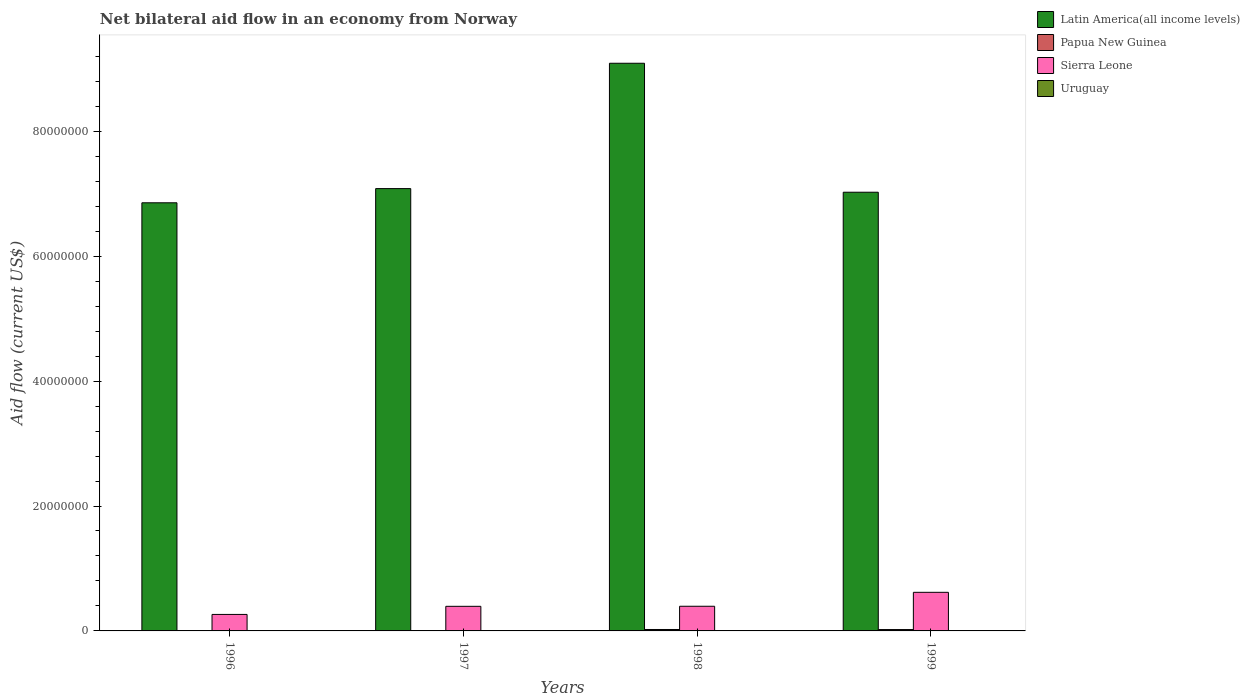How many groups of bars are there?
Offer a terse response. 4. How many bars are there on the 1st tick from the left?
Ensure brevity in your answer.  4. What is the label of the 3rd group of bars from the left?
Offer a terse response. 1998. In how many cases, is the number of bars for a given year not equal to the number of legend labels?
Offer a very short reply. 0. What is the net bilateral aid flow in Sierra Leone in 1999?
Offer a terse response. 6.18e+06. Across all years, what is the maximum net bilateral aid flow in Sierra Leone?
Provide a succinct answer. 6.18e+06. Across all years, what is the minimum net bilateral aid flow in Sierra Leone?
Your response must be concise. 2.64e+06. In which year was the net bilateral aid flow in Papua New Guinea maximum?
Your answer should be compact. 1998. What is the difference between the net bilateral aid flow in Uruguay in 1996 and that in 1997?
Offer a terse response. 3.00e+04. What is the difference between the net bilateral aid flow in Uruguay in 1997 and the net bilateral aid flow in Sierra Leone in 1999?
Your answer should be compact. -6.16e+06. What is the average net bilateral aid flow in Papua New Guinea per year?
Your answer should be compact. 1.28e+05. In the year 1999, what is the difference between the net bilateral aid flow in Uruguay and net bilateral aid flow in Sierra Leone?
Offer a very short reply. -6.13e+06. In how many years, is the net bilateral aid flow in Sierra Leone greater than 84000000 US$?
Ensure brevity in your answer.  0. What is the ratio of the net bilateral aid flow in Sierra Leone in 1996 to that in 1999?
Ensure brevity in your answer.  0.43. Is the net bilateral aid flow in Latin America(all income levels) in 1996 less than that in 1999?
Provide a succinct answer. Yes. Is the difference between the net bilateral aid flow in Uruguay in 1996 and 1998 greater than the difference between the net bilateral aid flow in Sierra Leone in 1996 and 1998?
Provide a short and direct response. Yes. What is the difference between the highest and the second highest net bilateral aid flow in Uruguay?
Offer a terse response. 0. In how many years, is the net bilateral aid flow in Sierra Leone greater than the average net bilateral aid flow in Sierra Leone taken over all years?
Your answer should be very brief. 1. What does the 4th bar from the left in 1997 represents?
Your response must be concise. Uruguay. What does the 2nd bar from the right in 1996 represents?
Keep it short and to the point. Sierra Leone. Is it the case that in every year, the sum of the net bilateral aid flow in Latin America(all income levels) and net bilateral aid flow in Uruguay is greater than the net bilateral aid flow in Papua New Guinea?
Ensure brevity in your answer.  Yes. How many bars are there?
Give a very brief answer. 16. Are all the bars in the graph horizontal?
Provide a succinct answer. No. What is the difference between two consecutive major ticks on the Y-axis?
Ensure brevity in your answer.  2.00e+07. Does the graph contain any zero values?
Your answer should be compact. No. How many legend labels are there?
Provide a succinct answer. 4. What is the title of the graph?
Provide a short and direct response. Net bilateral aid flow in an economy from Norway. Does "Lesotho" appear as one of the legend labels in the graph?
Offer a very short reply. No. What is the Aid flow (current US$) in Latin America(all income levels) in 1996?
Provide a succinct answer. 6.86e+07. What is the Aid flow (current US$) of Sierra Leone in 1996?
Ensure brevity in your answer.  2.64e+06. What is the Aid flow (current US$) of Latin America(all income levels) in 1997?
Offer a very short reply. 7.08e+07. What is the Aid flow (current US$) in Papua New Guinea in 1997?
Your answer should be compact. 3.00e+04. What is the Aid flow (current US$) of Sierra Leone in 1997?
Make the answer very short. 3.94e+06. What is the Aid flow (current US$) of Latin America(all income levels) in 1998?
Make the answer very short. 9.09e+07. What is the Aid flow (current US$) of Papua New Guinea in 1998?
Your answer should be very brief. 2.30e+05. What is the Aid flow (current US$) of Sierra Leone in 1998?
Keep it short and to the point. 3.95e+06. What is the Aid flow (current US$) in Latin America(all income levels) in 1999?
Provide a succinct answer. 7.02e+07. What is the Aid flow (current US$) of Sierra Leone in 1999?
Your answer should be compact. 6.18e+06. Across all years, what is the maximum Aid flow (current US$) in Latin America(all income levels)?
Offer a terse response. 9.09e+07. Across all years, what is the maximum Aid flow (current US$) of Sierra Leone?
Offer a terse response. 6.18e+06. Across all years, what is the maximum Aid flow (current US$) of Uruguay?
Keep it short and to the point. 5.00e+04. Across all years, what is the minimum Aid flow (current US$) of Latin America(all income levels)?
Offer a very short reply. 6.86e+07. Across all years, what is the minimum Aid flow (current US$) in Sierra Leone?
Offer a very short reply. 2.64e+06. What is the total Aid flow (current US$) of Latin America(all income levels) in the graph?
Your answer should be very brief. 3.00e+08. What is the total Aid flow (current US$) of Papua New Guinea in the graph?
Your answer should be compact. 5.10e+05. What is the total Aid flow (current US$) of Sierra Leone in the graph?
Give a very brief answer. 1.67e+07. What is the total Aid flow (current US$) in Uruguay in the graph?
Offer a very short reply. 1.60e+05. What is the difference between the Aid flow (current US$) in Latin America(all income levels) in 1996 and that in 1997?
Your answer should be very brief. -2.27e+06. What is the difference between the Aid flow (current US$) of Papua New Guinea in 1996 and that in 1997?
Offer a terse response. 0. What is the difference between the Aid flow (current US$) of Sierra Leone in 1996 and that in 1997?
Offer a very short reply. -1.30e+06. What is the difference between the Aid flow (current US$) of Uruguay in 1996 and that in 1997?
Your response must be concise. 3.00e+04. What is the difference between the Aid flow (current US$) in Latin America(all income levels) in 1996 and that in 1998?
Your answer should be very brief. -2.23e+07. What is the difference between the Aid flow (current US$) in Sierra Leone in 1996 and that in 1998?
Your answer should be very brief. -1.31e+06. What is the difference between the Aid flow (current US$) of Latin America(all income levels) in 1996 and that in 1999?
Your answer should be very brief. -1.69e+06. What is the difference between the Aid flow (current US$) in Papua New Guinea in 1996 and that in 1999?
Offer a very short reply. -1.90e+05. What is the difference between the Aid flow (current US$) in Sierra Leone in 1996 and that in 1999?
Keep it short and to the point. -3.54e+06. What is the difference between the Aid flow (current US$) of Uruguay in 1996 and that in 1999?
Make the answer very short. 0. What is the difference between the Aid flow (current US$) in Latin America(all income levels) in 1997 and that in 1998?
Make the answer very short. -2.01e+07. What is the difference between the Aid flow (current US$) of Papua New Guinea in 1997 and that in 1998?
Provide a succinct answer. -2.00e+05. What is the difference between the Aid flow (current US$) of Uruguay in 1997 and that in 1998?
Keep it short and to the point. -2.00e+04. What is the difference between the Aid flow (current US$) in Latin America(all income levels) in 1997 and that in 1999?
Provide a succinct answer. 5.80e+05. What is the difference between the Aid flow (current US$) in Papua New Guinea in 1997 and that in 1999?
Provide a short and direct response. -1.90e+05. What is the difference between the Aid flow (current US$) of Sierra Leone in 1997 and that in 1999?
Offer a terse response. -2.24e+06. What is the difference between the Aid flow (current US$) in Latin America(all income levels) in 1998 and that in 1999?
Your answer should be very brief. 2.06e+07. What is the difference between the Aid flow (current US$) in Sierra Leone in 1998 and that in 1999?
Give a very brief answer. -2.23e+06. What is the difference between the Aid flow (current US$) of Latin America(all income levels) in 1996 and the Aid flow (current US$) of Papua New Guinea in 1997?
Give a very brief answer. 6.85e+07. What is the difference between the Aid flow (current US$) of Latin America(all income levels) in 1996 and the Aid flow (current US$) of Sierra Leone in 1997?
Keep it short and to the point. 6.46e+07. What is the difference between the Aid flow (current US$) in Latin America(all income levels) in 1996 and the Aid flow (current US$) in Uruguay in 1997?
Keep it short and to the point. 6.85e+07. What is the difference between the Aid flow (current US$) in Papua New Guinea in 1996 and the Aid flow (current US$) in Sierra Leone in 1997?
Your answer should be very brief. -3.91e+06. What is the difference between the Aid flow (current US$) of Papua New Guinea in 1996 and the Aid flow (current US$) of Uruguay in 1997?
Your answer should be very brief. 10000. What is the difference between the Aid flow (current US$) in Sierra Leone in 1996 and the Aid flow (current US$) in Uruguay in 1997?
Provide a succinct answer. 2.62e+06. What is the difference between the Aid flow (current US$) in Latin America(all income levels) in 1996 and the Aid flow (current US$) in Papua New Guinea in 1998?
Provide a succinct answer. 6.83e+07. What is the difference between the Aid flow (current US$) in Latin America(all income levels) in 1996 and the Aid flow (current US$) in Sierra Leone in 1998?
Ensure brevity in your answer.  6.46e+07. What is the difference between the Aid flow (current US$) of Latin America(all income levels) in 1996 and the Aid flow (current US$) of Uruguay in 1998?
Provide a succinct answer. 6.85e+07. What is the difference between the Aid flow (current US$) in Papua New Guinea in 1996 and the Aid flow (current US$) in Sierra Leone in 1998?
Give a very brief answer. -3.92e+06. What is the difference between the Aid flow (current US$) of Papua New Guinea in 1996 and the Aid flow (current US$) of Uruguay in 1998?
Ensure brevity in your answer.  -10000. What is the difference between the Aid flow (current US$) in Sierra Leone in 1996 and the Aid flow (current US$) in Uruguay in 1998?
Your response must be concise. 2.60e+06. What is the difference between the Aid flow (current US$) of Latin America(all income levels) in 1996 and the Aid flow (current US$) of Papua New Guinea in 1999?
Provide a succinct answer. 6.83e+07. What is the difference between the Aid flow (current US$) of Latin America(all income levels) in 1996 and the Aid flow (current US$) of Sierra Leone in 1999?
Keep it short and to the point. 6.24e+07. What is the difference between the Aid flow (current US$) in Latin America(all income levels) in 1996 and the Aid flow (current US$) in Uruguay in 1999?
Keep it short and to the point. 6.85e+07. What is the difference between the Aid flow (current US$) of Papua New Guinea in 1996 and the Aid flow (current US$) of Sierra Leone in 1999?
Your answer should be very brief. -6.15e+06. What is the difference between the Aid flow (current US$) in Sierra Leone in 1996 and the Aid flow (current US$) in Uruguay in 1999?
Your answer should be compact. 2.59e+06. What is the difference between the Aid flow (current US$) of Latin America(all income levels) in 1997 and the Aid flow (current US$) of Papua New Guinea in 1998?
Provide a succinct answer. 7.06e+07. What is the difference between the Aid flow (current US$) of Latin America(all income levels) in 1997 and the Aid flow (current US$) of Sierra Leone in 1998?
Your answer should be compact. 6.69e+07. What is the difference between the Aid flow (current US$) of Latin America(all income levels) in 1997 and the Aid flow (current US$) of Uruguay in 1998?
Keep it short and to the point. 7.08e+07. What is the difference between the Aid flow (current US$) of Papua New Guinea in 1997 and the Aid flow (current US$) of Sierra Leone in 1998?
Offer a very short reply. -3.92e+06. What is the difference between the Aid flow (current US$) in Papua New Guinea in 1997 and the Aid flow (current US$) in Uruguay in 1998?
Your answer should be compact. -10000. What is the difference between the Aid flow (current US$) in Sierra Leone in 1997 and the Aid flow (current US$) in Uruguay in 1998?
Make the answer very short. 3.90e+06. What is the difference between the Aid flow (current US$) in Latin America(all income levels) in 1997 and the Aid flow (current US$) in Papua New Guinea in 1999?
Your answer should be very brief. 7.06e+07. What is the difference between the Aid flow (current US$) in Latin America(all income levels) in 1997 and the Aid flow (current US$) in Sierra Leone in 1999?
Make the answer very short. 6.46e+07. What is the difference between the Aid flow (current US$) of Latin America(all income levels) in 1997 and the Aid flow (current US$) of Uruguay in 1999?
Your answer should be compact. 7.08e+07. What is the difference between the Aid flow (current US$) of Papua New Guinea in 1997 and the Aid flow (current US$) of Sierra Leone in 1999?
Your answer should be very brief. -6.15e+06. What is the difference between the Aid flow (current US$) in Sierra Leone in 1997 and the Aid flow (current US$) in Uruguay in 1999?
Your answer should be compact. 3.89e+06. What is the difference between the Aid flow (current US$) in Latin America(all income levels) in 1998 and the Aid flow (current US$) in Papua New Guinea in 1999?
Provide a short and direct response. 9.07e+07. What is the difference between the Aid flow (current US$) in Latin America(all income levels) in 1998 and the Aid flow (current US$) in Sierra Leone in 1999?
Give a very brief answer. 8.47e+07. What is the difference between the Aid flow (current US$) in Latin America(all income levels) in 1998 and the Aid flow (current US$) in Uruguay in 1999?
Offer a very short reply. 9.08e+07. What is the difference between the Aid flow (current US$) of Papua New Guinea in 1998 and the Aid flow (current US$) of Sierra Leone in 1999?
Your answer should be very brief. -5.95e+06. What is the difference between the Aid flow (current US$) of Papua New Guinea in 1998 and the Aid flow (current US$) of Uruguay in 1999?
Offer a very short reply. 1.80e+05. What is the difference between the Aid flow (current US$) in Sierra Leone in 1998 and the Aid flow (current US$) in Uruguay in 1999?
Provide a short and direct response. 3.90e+06. What is the average Aid flow (current US$) in Latin America(all income levels) per year?
Keep it short and to the point. 7.51e+07. What is the average Aid flow (current US$) in Papua New Guinea per year?
Make the answer very short. 1.28e+05. What is the average Aid flow (current US$) in Sierra Leone per year?
Your answer should be compact. 4.18e+06. In the year 1996, what is the difference between the Aid flow (current US$) in Latin America(all income levels) and Aid flow (current US$) in Papua New Guinea?
Ensure brevity in your answer.  6.85e+07. In the year 1996, what is the difference between the Aid flow (current US$) of Latin America(all income levels) and Aid flow (current US$) of Sierra Leone?
Your answer should be very brief. 6.59e+07. In the year 1996, what is the difference between the Aid flow (current US$) of Latin America(all income levels) and Aid flow (current US$) of Uruguay?
Ensure brevity in your answer.  6.85e+07. In the year 1996, what is the difference between the Aid flow (current US$) in Papua New Guinea and Aid flow (current US$) in Sierra Leone?
Your answer should be very brief. -2.61e+06. In the year 1996, what is the difference between the Aid flow (current US$) in Papua New Guinea and Aid flow (current US$) in Uruguay?
Ensure brevity in your answer.  -2.00e+04. In the year 1996, what is the difference between the Aid flow (current US$) of Sierra Leone and Aid flow (current US$) of Uruguay?
Provide a short and direct response. 2.59e+06. In the year 1997, what is the difference between the Aid flow (current US$) in Latin America(all income levels) and Aid flow (current US$) in Papua New Guinea?
Your response must be concise. 7.08e+07. In the year 1997, what is the difference between the Aid flow (current US$) of Latin America(all income levels) and Aid flow (current US$) of Sierra Leone?
Offer a terse response. 6.69e+07. In the year 1997, what is the difference between the Aid flow (current US$) of Latin America(all income levels) and Aid flow (current US$) of Uruguay?
Give a very brief answer. 7.08e+07. In the year 1997, what is the difference between the Aid flow (current US$) of Papua New Guinea and Aid flow (current US$) of Sierra Leone?
Keep it short and to the point. -3.91e+06. In the year 1997, what is the difference between the Aid flow (current US$) in Sierra Leone and Aid flow (current US$) in Uruguay?
Ensure brevity in your answer.  3.92e+06. In the year 1998, what is the difference between the Aid flow (current US$) in Latin America(all income levels) and Aid flow (current US$) in Papua New Guinea?
Offer a very short reply. 9.07e+07. In the year 1998, what is the difference between the Aid flow (current US$) in Latin America(all income levels) and Aid flow (current US$) in Sierra Leone?
Give a very brief answer. 8.69e+07. In the year 1998, what is the difference between the Aid flow (current US$) in Latin America(all income levels) and Aid flow (current US$) in Uruguay?
Your answer should be compact. 9.08e+07. In the year 1998, what is the difference between the Aid flow (current US$) in Papua New Guinea and Aid flow (current US$) in Sierra Leone?
Offer a terse response. -3.72e+06. In the year 1998, what is the difference between the Aid flow (current US$) in Sierra Leone and Aid flow (current US$) in Uruguay?
Your answer should be compact. 3.91e+06. In the year 1999, what is the difference between the Aid flow (current US$) of Latin America(all income levels) and Aid flow (current US$) of Papua New Guinea?
Your response must be concise. 7.00e+07. In the year 1999, what is the difference between the Aid flow (current US$) of Latin America(all income levels) and Aid flow (current US$) of Sierra Leone?
Your response must be concise. 6.41e+07. In the year 1999, what is the difference between the Aid flow (current US$) in Latin America(all income levels) and Aid flow (current US$) in Uruguay?
Your answer should be very brief. 7.02e+07. In the year 1999, what is the difference between the Aid flow (current US$) in Papua New Guinea and Aid flow (current US$) in Sierra Leone?
Offer a terse response. -5.96e+06. In the year 1999, what is the difference between the Aid flow (current US$) in Sierra Leone and Aid flow (current US$) in Uruguay?
Provide a short and direct response. 6.13e+06. What is the ratio of the Aid flow (current US$) in Latin America(all income levels) in 1996 to that in 1997?
Offer a terse response. 0.97. What is the ratio of the Aid flow (current US$) in Papua New Guinea in 1996 to that in 1997?
Offer a terse response. 1. What is the ratio of the Aid flow (current US$) of Sierra Leone in 1996 to that in 1997?
Offer a terse response. 0.67. What is the ratio of the Aid flow (current US$) in Latin America(all income levels) in 1996 to that in 1998?
Make the answer very short. 0.75. What is the ratio of the Aid flow (current US$) of Papua New Guinea in 1996 to that in 1998?
Provide a short and direct response. 0.13. What is the ratio of the Aid flow (current US$) in Sierra Leone in 1996 to that in 1998?
Make the answer very short. 0.67. What is the ratio of the Aid flow (current US$) of Uruguay in 1996 to that in 1998?
Ensure brevity in your answer.  1.25. What is the ratio of the Aid flow (current US$) in Latin America(all income levels) in 1996 to that in 1999?
Offer a terse response. 0.98. What is the ratio of the Aid flow (current US$) in Papua New Guinea in 1996 to that in 1999?
Give a very brief answer. 0.14. What is the ratio of the Aid flow (current US$) in Sierra Leone in 1996 to that in 1999?
Give a very brief answer. 0.43. What is the ratio of the Aid flow (current US$) of Latin America(all income levels) in 1997 to that in 1998?
Keep it short and to the point. 0.78. What is the ratio of the Aid flow (current US$) of Papua New Guinea in 1997 to that in 1998?
Provide a succinct answer. 0.13. What is the ratio of the Aid flow (current US$) of Uruguay in 1997 to that in 1998?
Your response must be concise. 0.5. What is the ratio of the Aid flow (current US$) of Latin America(all income levels) in 1997 to that in 1999?
Offer a very short reply. 1.01. What is the ratio of the Aid flow (current US$) of Papua New Guinea in 1997 to that in 1999?
Give a very brief answer. 0.14. What is the ratio of the Aid flow (current US$) of Sierra Leone in 1997 to that in 1999?
Keep it short and to the point. 0.64. What is the ratio of the Aid flow (current US$) in Uruguay in 1997 to that in 1999?
Make the answer very short. 0.4. What is the ratio of the Aid flow (current US$) in Latin America(all income levels) in 1998 to that in 1999?
Give a very brief answer. 1.29. What is the ratio of the Aid flow (current US$) in Papua New Guinea in 1998 to that in 1999?
Make the answer very short. 1.05. What is the ratio of the Aid flow (current US$) of Sierra Leone in 1998 to that in 1999?
Your response must be concise. 0.64. What is the difference between the highest and the second highest Aid flow (current US$) of Latin America(all income levels)?
Provide a succinct answer. 2.01e+07. What is the difference between the highest and the second highest Aid flow (current US$) in Sierra Leone?
Make the answer very short. 2.23e+06. What is the difference between the highest and the second highest Aid flow (current US$) in Uruguay?
Offer a terse response. 0. What is the difference between the highest and the lowest Aid flow (current US$) in Latin America(all income levels)?
Provide a succinct answer. 2.23e+07. What is the difference between the highest and the lowest Aid flow (current US$) of Papua New Guinea?
Offer a terse response. 2.00e+05. What is the difference between the highest and the lowest Aid flow (current US$) of Sierra Leone?
Provide a short and direct response. 3.54e+06. 